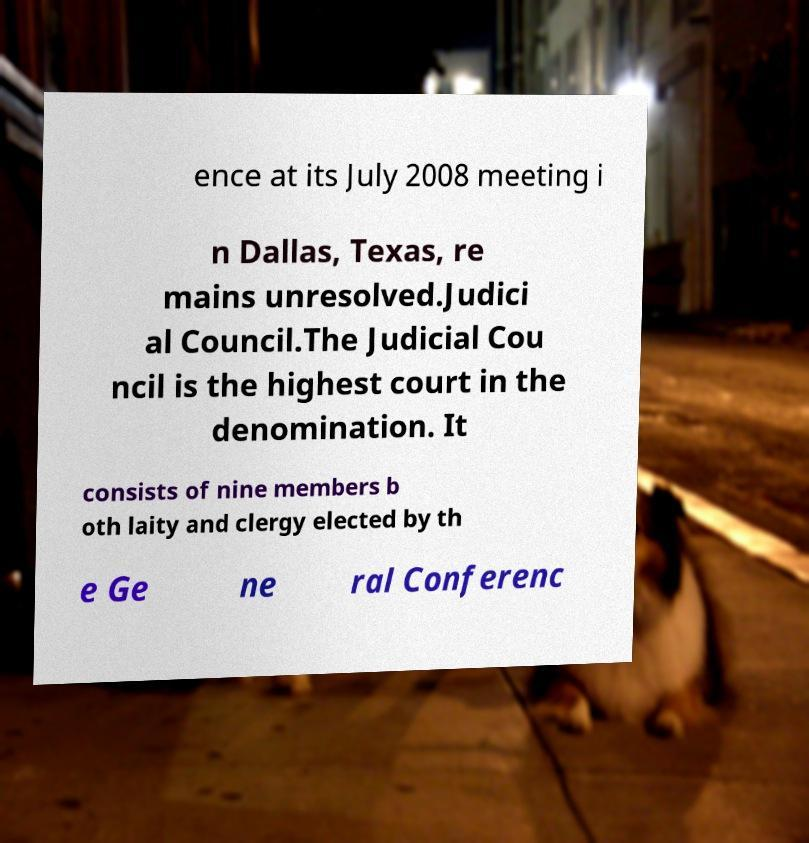Please read and relay the text visible in this image. What does it say? ence at its July 2008 meeting i n Dallas, Texas, re mains unresolved.Judici al Council.The Judicial Cou ncil is the highest court in the denomination. It consists of nine members b oth laity and clergy elected by th e Ge ne ral Conferenc 